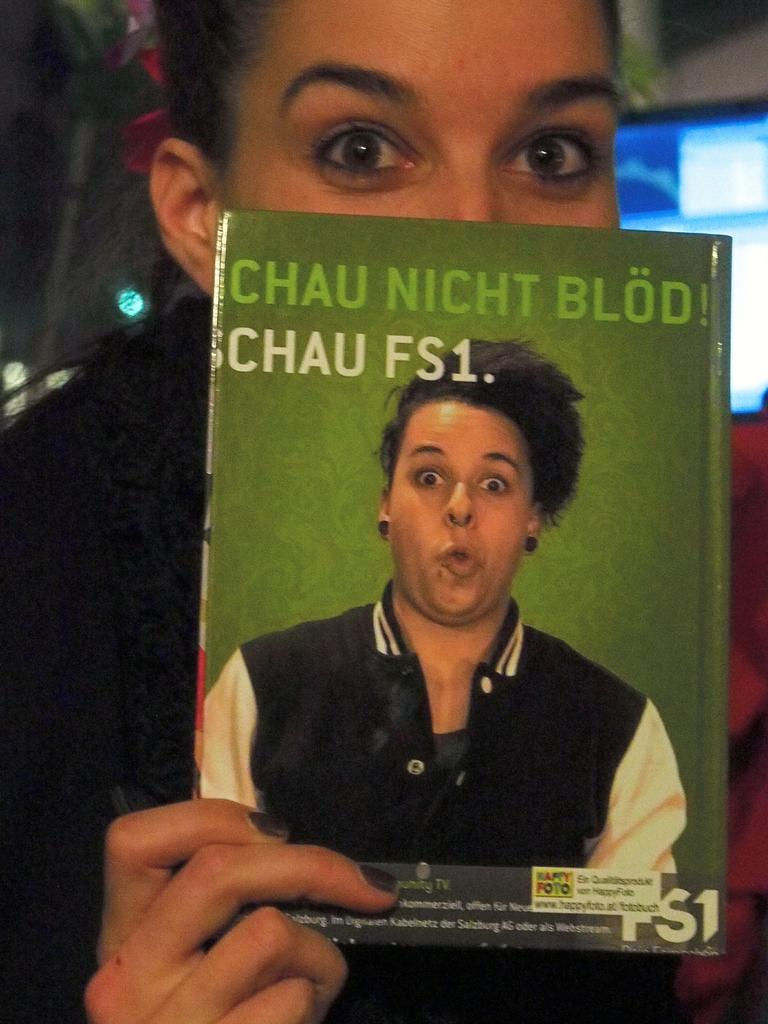Who is the main subject in the image? There is a woman in the image. What is the woman wearing? The woman is wearing a black dress. What is the woman holding in the image? The woman is holding a book. What else can be seen in the image besides the woman and the book? There are other things visible behind the woman. What type of corn is being served in the image? There is no corn present in the image. Is the eggnog being poured into a glass in the image? There is no eggnog present in the image. 